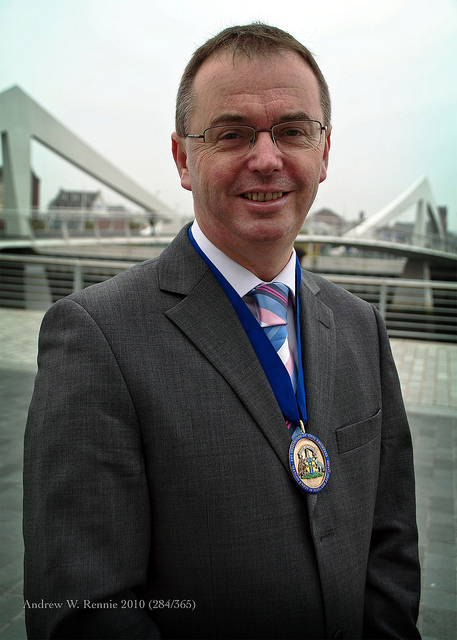Identify the text contained in this image. 365 (284 2010 Rennie W. Andrew 